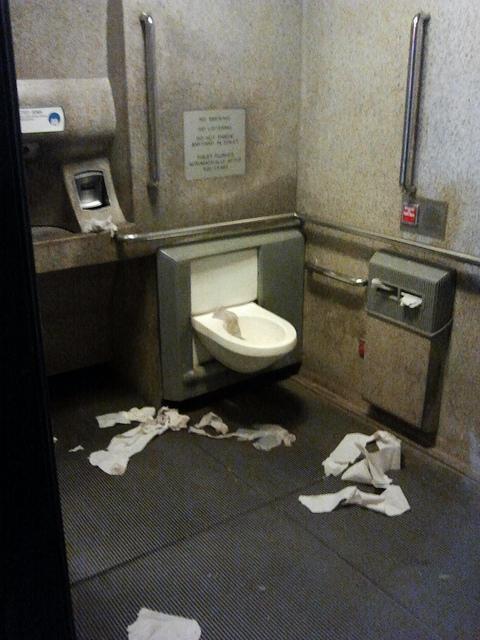How many beds in this image require a ladder to get into?
Give a very brief answer. 0. 